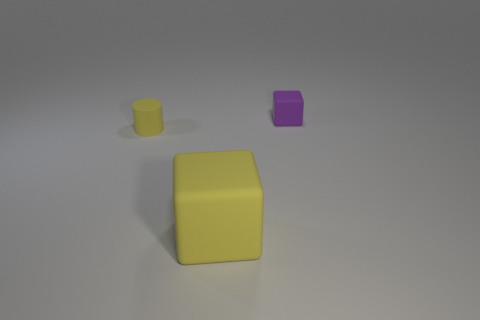Are there any other things that have the same size as the yellow block?
Ensure brevity in your answer.  No. What is the shape of the matte thing that is the same color as the small cylinder?
Your answer should be compact. Cube. What size is the thing that is the same color as the big cube?
Your response must be concise. Small. What material is the object that is the same color as the small rubber cylinder?
Ensure brevity in your answer.  Rubber. Are there more cylinders to the right of the small yellow rubber object than blue shiny objects?
Your response must be concise. No. What shape is the tiny thing in front of the rubber block that is behind the block in front of the yellow cylinder?
Make the answer very short. Cylinder. Do the small object that is left of the purple rubber thing and the tiny matte object right of the large object have the same shape?
Your response must be concise. No. How many cylinders are tiny purple things or matte things?
Give a very brief answer. 1. Are the purple object and the tiny cylinder made of the same material?
Provide a succinct answer. Yes. How many other things are there of the same color as the small block?
Provide a short and direct response. 0. 